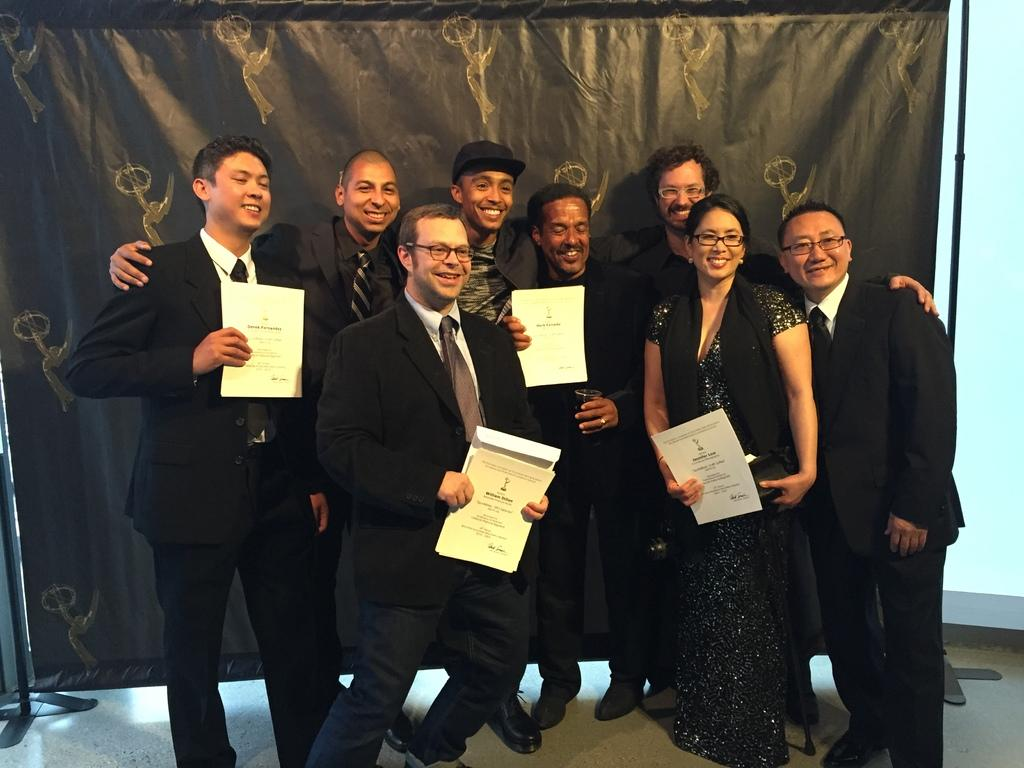How many people are in the image? There are men and a woman in the image, making a total of at least three people. What is the woman wearing in the image? The woman is wearing a black dress in the image. What is the woman holding in the image? The woman is holding papers in the image. What is the background of the image? The people are standing in front of a black curtain, with a wall behind the curtain. What type of secretary is visible in the image? There is no secretary present in the image. Can you describe the steam coming from the thing in the image? There is no thing or steam present in the image. 